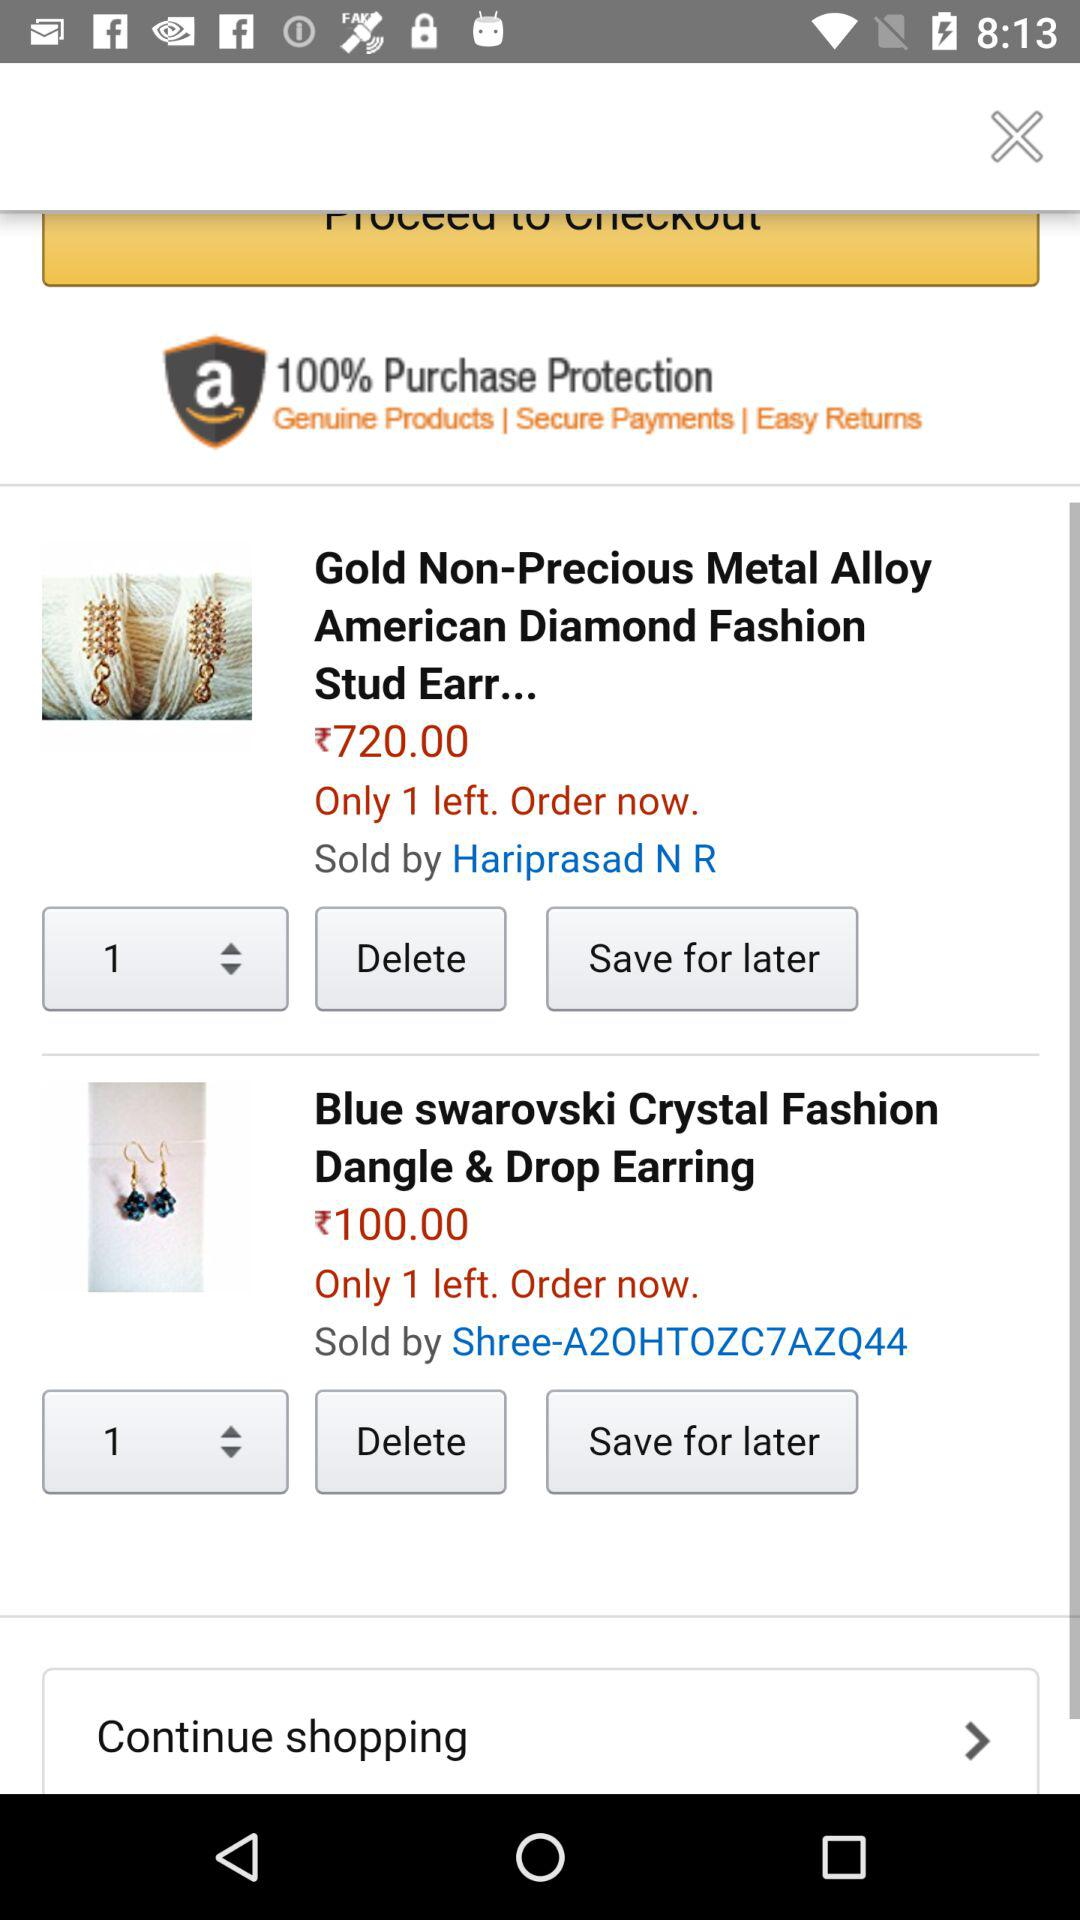What is the price of the "Blue swarovski Crystal Fashion Dangle & Drop Earring"? The price is ₹100. 